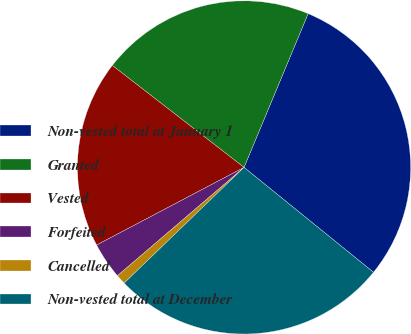Convert chart to OTSL. <chart><loc_0><loc_0><loc_500><loc_500><pie_chart><fcel>Non-vested total at January 1<fcel>Granted<fcel>Vested<fcel>Forfeited<fcel>Cancelled<fcel>Non-vested total at December<nl><fcel>29.55%<fcel>20.8%<fcel>18.2%<fcel>3.55%<fcel>0.95%<fcel>26.95%<nl></chart> 